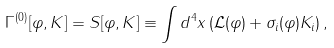<formula> <loc_0><loc_0><loc_500><loc_500>\Gamma ^ { ( 0 ) } [ \varphi , K ] = S [ \varphi , K ] \equiv \int d ^ { 4 } x \left ( \mathcal { L } ( \varphi ) + \sigma _ { i } ( \varphi ) K _ { i } \right ) ,</formula> 